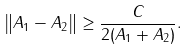<formula> <loc_0><loc_0><loc_500><loc_500>\left \| A _ { 1 } - A _ { 2 } \right \| \geq \frac { C } { 2 ( \| A _ { 1 } \| + \| A _ { 2 } \| ) } .</formula> 